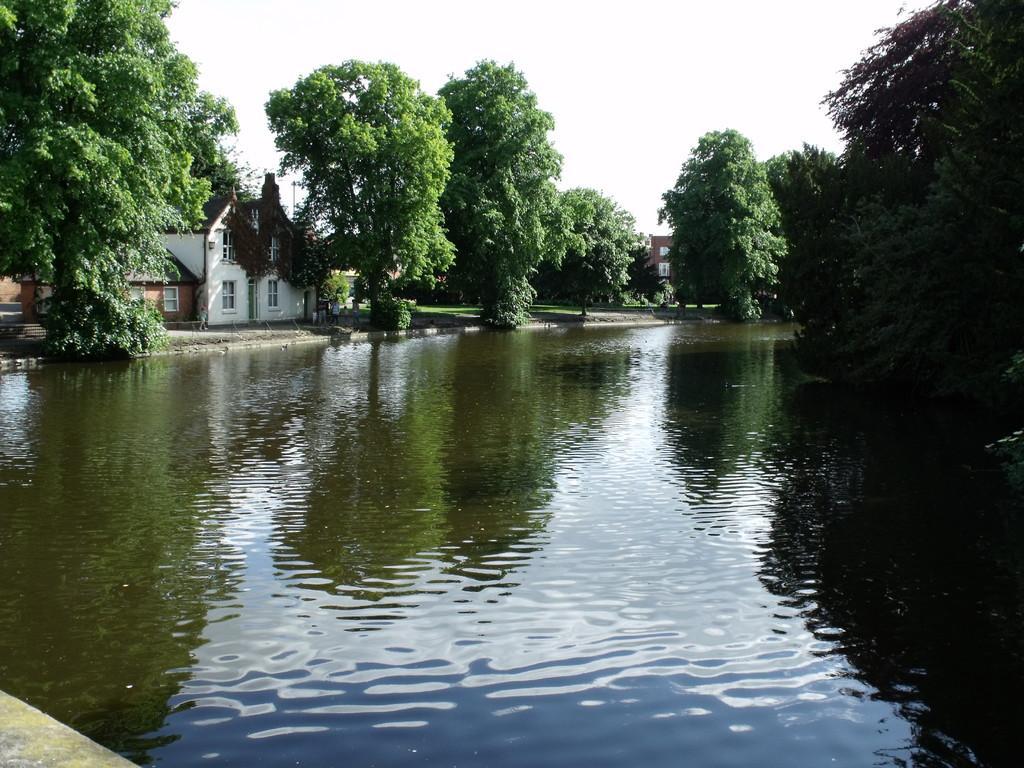Can you describe this image briefly? In this picture we can see water, few trees and buildings. 